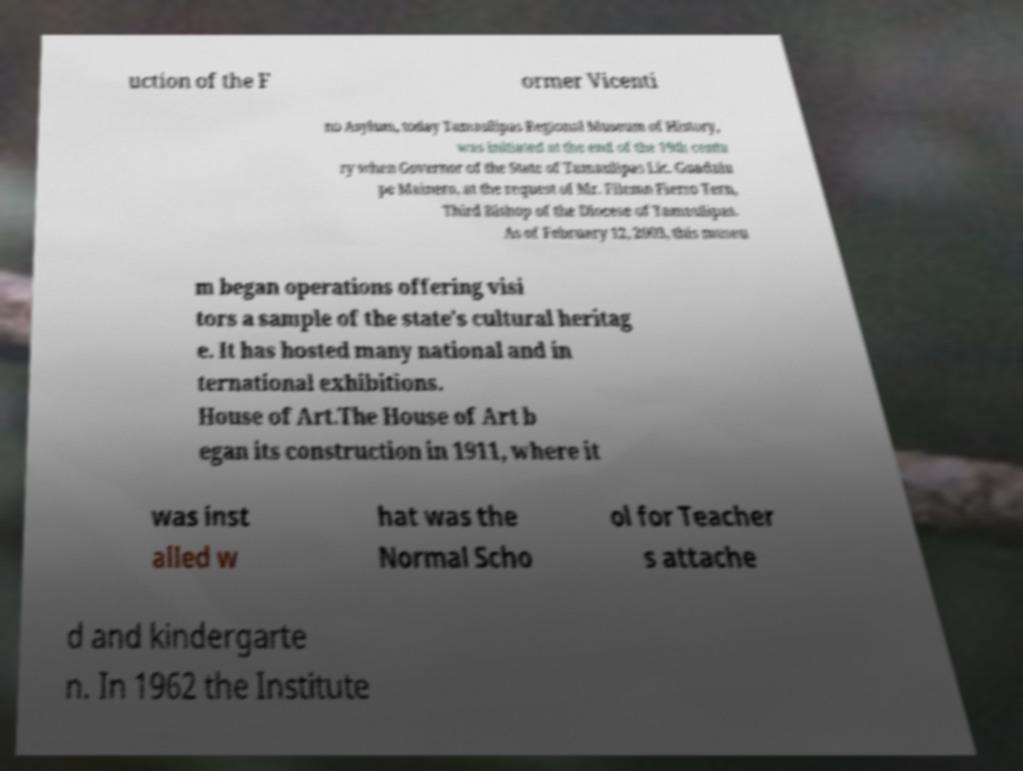Please read and relay the text visible in this image. What does it say? uction of the F ormer Vicenti no Asylum, today Tamaulipas Regional Museum of History, was initiated at the end of the 19th centu ry when Governor of the State of Tamaulipas Lic. Guadalu pe Mainero, at the request of Mr. Filemn Fierro Tern, Third Bishop of the Diocese of Tamaulipas. As of February 12, 2003, this museu m began operations offering visi tors a sample of the state's cultural heritag e. It has hosted many national and in ternational exhibitions. House of Art.The House of Art b egan its construction in 1911, where it was inst alled w hat was the Normal Scho ol for Teacher s attache d and kindergarte n. In 1962 the Institute 